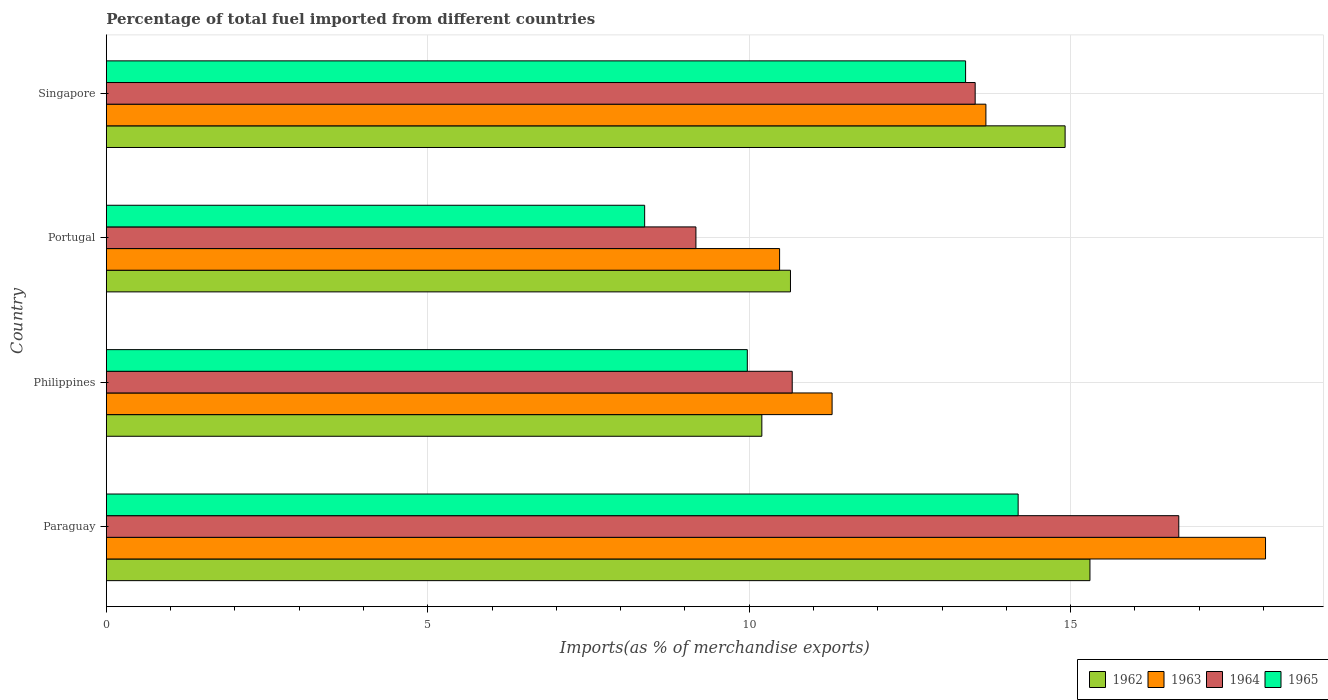Are the number of bars on each tick of the Y-axis equal?
Your answer should be very brief. Yes. How many bars are there on the 3rd tick from the top?
Ensure brevity in your answer.  4. What is the label of the 1st group of bars from the top?
Provide a succinct answer. Singapore. In how many cases, is the number of bars for a given country not equal to the number of legend labels?
Offer a very short reply. 0. What is the percentage of imports to different countries in 1964 in Portugal?
Your response must be concise. 9.17. Across all countries, what is the maximum percentage of imports to different countries in 1962?
Give a very brief answer. 15.3. Across all countries, what is the minimum percentage of imports to different countries in 1964?
Ensure brevity in your answer.  9.17. In which country was the percentage of imports to different countries in 1963 maximum?
Your answer should be compact. Paraguay. What is the total percentage of imports to different countries in 1964 in the graph?
Offer a terse response. 50.03. What is the difference between the percentage of imports to different countries in 1965 in Portugal and that in Singapore?
Your answer should be very brief. -4.99. What is the difference between the percentage of imports to different countries in 1965 in Paraguay and the percentage of imports to different countries in 1964 in Singapore?
Provide a short and direct response. 0.67. What is the average percentage of imports to different countries in 1962 per country?
Give a very brief answer. 12.76. What is the difference between the percentage of imports to different countries in 1962 and percentage of imports to different countries in 1963 in Paraguay?
Give a very brief answer. -2.73. In how many countries, is the percentage of imports to different countries in 1964 greater than 5 %?
Ensure brevity in your answer.  4. What is the ratio of the percentage of imports to different countries in 1962 in Philippines to that in Singapore?
Your answer should be very brief. 0.68. Is the percentage of imports to different countries in 1963 in Philippines less than that in Portugal?
Make the answer very short. No. What is the difference between the highest and the second highest percentage of imports to different countries in 1964?
Your answer should be compact. 3.17. What is the difference between the highest and the lowest percentage of imports to different countries in 1963?
Provide a short and direct response. 7.56. Is the sum of the percentage of imports to different countries in 1965 in Philippines and Portugal greater than the maximum percentage of imports to different countries in 1962 across all countries?
Give a very brief answer. Yes. Is it the case that in every country, the sum of the percentage of imports to different countries in 1963 and percentage of imports to different countries in 1964 is greater than the sum of percentage of imports to different countries in 1962 and percentage of imports to different countries in 1965?
Make the answer very short. No. What does the 4th bar from the top in Singapore represents?
Your answer should be very brief. 1962. What does the 4th bar from the bottom in Portugal represents?
Your answer should be very brief. 1965. Is it the case that in every country, the sum of the percentage of imports to different countries in 1964 and percentage of imports to different countries in 1965 is greater than the percentage of imports to different countries in 1962?
Provide a short and direct response. Yes. Are all the bars in the graph horizontal?
Provide a short and direct response. Yes. How many countries are there in the graph?
Provide a short and direct response. 4. What is the difference between two consecutive major ticks on the X-axis?
Offer a very short reply. 5. Are the values on the major ticks of X-axis written in scientific E-notation?
Provide a succinct answer. No. How are the legend labels stacked?
Provide a short and direct response. Horizontal. What is the title of the graph?
Your answer should be compact. Percentage of total fuel imported from different countries. Does "1964" appear as one of the legend labels in the graph?
Your answer should be very brief. Yes. What is the label or title of the X-axis?
Offer a very short reply. Imports(as % of merchandise exports). What is the Imports(as % of merchandise exports) of 1962 in Paraguay?
Offer a terse response. 15.3. What is the Imports(as % of merchandise exports) in 1963 in Paraguay?
Give a very brief answer. 18.03. What is the Imports(as % of merchandise exports) of 1964 in Paraguay?
Give a very brief answer. 16.68. What is the Imports(as % of merchandise exports) in 1965 in Paraguay?
Your response must be concise. 14.18. What is the Imports(as % of merchandise exports) of 1962 in Philippines?
Make the answer very short. 10.2. What is the Imports(as % of merchandise exports) of 1963 in Philippines?
Offer a very short reply. 11.29. What is the Imports(as % of merchandise exports) of 1964 in Philippines?
Keep it short and to the point. 10.67. What is the Imports(as % of merchandise exports) in 1965 in Philippines?
Offer a very short reply. 9.97. What is the Imports(as % of merchandise exports) of 1962 in Portugal?
Your response must be concise. 10.64. What is the Imports(as % of merchandise exports) in 1963 in Portugal?
Offer a very short reply. 10.47. What is the Imports(as % of merchandise exports) in 1964 in Portugal?
Offer a very short reply. 9.17. What is the Imports(as % of merchandise exports) of 1965 in Portugal?
Give a very brief answer. 8.37. What is the Imports(as % of merchandise exports) in 1962 in Singapore?
Offer a terse response. 14.91. What is the Imports(as % of merchandise exports) in 1963 in Singapore?
Your response must be concise. 13.68. What is the Imports(as % of merchandise exports) in 1964 in Singapore?
Your answer should be very brief. 13.51. What is the Imports(as % of merchandise exports) of 1965 in Singapore?
Offer a very short reply. 13.37. Across all countries, what is the maximum Imports(as % of merchandise exports) of 1962?
Your answer should be very brief. 15.3. Across all countries, what is the maximum Imports(as % of merchandise exports) of 1963?
Provide a succinct answer. 18.03. Across all countries, what is the maximum Imports(as % of merchandise exports) of 1964?
Your response must be concise. 16.68. Across all countries, what is the maximum Imports(as % of merchandise exports) in 1965?
Provide a succinct answer. 14.18. Across all countries, what is the minimum Imports(as % of merchandise exports) of 1962?
Offer a terse response. 10.2. Across all countries, what is the minimum Imports(as % of merchandise exports) of 1963?
Make the answer very short. 10.47. Across all countries, what is the minimum Imports(as % of merchandise exports) in 1964?
Offer a very short reply. 9.17. Across all countries, what is the minimum Imports(as % of merchandise exports) in 1965?
Your answer should be compact. 8.37. What is the total Imports(as % of merchandise exports) of 1962 in the graph?
Provide a short and direct response. 51.05. What is the total Imports(as % of merchandise exports) in 1963 in the graph?
Offer a very short reply. 53.47. What is the total Imports(as % of merchandise exports) of 1964 in the graph?
Offer a very short reply. 50.03. What is the total Imports(as % of merchandise exports) of 1965 in the graph?
Your response must be concise. 45.89. What is the difference between the Imports(as % of merchandise exports) in 1962 in Paraguay and that in Philippines?
Your answer should be very brief. 5.1. What is the difference between the Imports(as % of merchandise exports) of 1963 in Paraguay and that in Philippines?
Ensure brevity in your answer.  6.74. What is the difference between the Imports(as % of merchandise exports) of 1964 in Paraguay and that in Philippines?
Offer a very short reply. 6.01. What is the difference between the Imports(as % of merchandise exports) in 1965 in Paraguay and that in Philippines?
Give a very brief answer. 4.21. What is the difference between the Imports(as % of merchandise exports) of 1962 in Paraguay and that in Portugal?
Offer a very short reply. 4.66. What is the difference between the Imports(as % of merchandise exports) in 1963 in Paraguay and that in Portugal?
Your answer should be very brief. 7.56. What is the difference between the Imports(as % of merchandise exports) of 1964 in Paraguay and that in Portugal?
Offer a very short reply. 7.51. What is the difference between the Imports(as % of merchandise exports) in 1965 in Paraguay and that in Portugal?
Make the answer very short. 5.81. What is the difference between the Imports(as % of merchandise exports) of 1962 in Paraguay and that in Singapore?
Ensure brevity in your answer.  0.39. What is the difference between the Imports(as % of merchandise exports) in 1963 in Paraguay and that in Singapore?
Your response must be concise. 4.35. What is the difference between the Imports(as % of merchandise exports) of 1964 in Paraguay and that in Singapore?
Provide a short and direct response. 3.17. What is the difference between the Imports(as % of merchandise exports) in 1965 in Paraguay and that in Singapore?
Your answer should be compact. 0.82. What is the difference between the Imports(as % of merchandise exports) in 1962 in Philippines and that in Portugal?
Offer a terse response. -0.45. What is the difference between the Imports(as % of merchandise exports) of 1963 in Philippines and that in Portugal?
Offer a very short reply. 0.82. What is the difference between the Imports(as % of merchandise exports) of 1964 in Philippines and that in Portugal?
Offer a terse response. 1.5. What is the difference between the Imports(as % of merchandise exports) in 1965 in Philippines and that in Portugal?
Offer a very short reply. 1.6. What is the difference between the Imports(as % of merchandise exports) in 1962 in Philippines and that in Singapore?
Make the answer very short. -4.72. What is the difference between the Imports(as % of merchandise exports) in 1963 in Philippines and that in Singapore?
Make the answer very short. -2.39. What is the difference between the Imports(as % of merchandise exports) in 1964 in Philippines and that in Singapore?
Make the answer very short. -2.85. What is the difference between the Imports(as % of merchandise exports) in 1965 in Philippines and that in Singapore?
Provide a short and direct response. -3.4. What is the difference between the Imports(as % of merchandise exports) of 1962 in Portugal and that in Singapore?
Ensure brevity in your answer.  -4.27. What is the difference between the Imports(as % of merchandise exports) of 1963 in Portugal and that in Singapore?
Make the answer very short. -3.21. What is the difference between the Imports(as % of merchandise exports) of 1964 in Portugal and that in Singapore?
Make the answer very short. -4.34. What is the difference between the Imports(as % of merchandise exports) in 1965 in Portugal and that in Singapore?
Your response must be concise. -4.99. What is the difference between the Imports(as % of merchandise exports) of 1962 in Paraguay and the Imports(as % of merchandise exports) of 1963 in Philippines?
Keep it short and to the point. 4.01. What is the difference between the Imports(as % of merchandise exports) of 1962 in Paraguay and the Imports(as % of merchandise exports) of 1964 in Philippines?
Ensure brevity in your answer.  4.63. What is the difference between the Imports(as % of merchandise exports) of 1962 in Paraguay and the Imports(as % of merchandise exports) of 1965 in Philippines?
Your answer should be very brief. 5.33. What is the difference between the Imports(as % of merchandise exports) in 1963 in Paraguay and the Imports(as % of merchandise exports) in 1964 in Philippines?
Your response must be concise. 7.36. What is the difference between the Imports(as % of merchandise exports) of 1963 in Paraguay and the Imports(as % of merchandise exports) of 1965 in Philippines?
Your answer should be compact. 8.06. What is the difference between the Imports(as % of merchandise exports) in 1964 in Paraguay and the Imports(as % of merchandise exports) in 1965 in Philippines?
Provide a succinct answer. 6.71. What is the difference between the Imports(as % of merchandise exports) in 1962 in Paraguay and the Imports(as % of merchandise exports) in 1963 in Portugal?
Your response must be concise. 4.83. What is the difference between the Imports(as % of merchandise exports) in 1962 in Paraguay and the Imports(as % of merchandise exports) in 1964 in Portugal?
Ensure brevity in your answer.  6.13. What is the difference between the Imports(as % of merchandise exports) of 1962 in Paraguay and the Imports(as % of merchandise exports) of 1965 in Portugal?
Provide a succinct answer. 6.93. What is the difference between the Imports(as % of merchandise exports) of 1963 in Paraguay and the Imports(as % of merchandise exports) of 1964 in Portugal?
Offer a terse response. 8.86. What is the difference between the Imports(as % of merchandise exports) of 1963 in Paraguay and the Imports(as % of merchandise exports) of 1965 in Portugal?
Your response must be concise. 9.66. What is the difference between the Imports(as % of merchandise exports) of 1964 in Paraguay and the Imports(as % of merchandise exports) of 1965 in Portugal?
Your response must be concise. 8.31. What is the difference between the Imports(as % of merchandise exports) in 1962 in Paraguay and the Imports(as % of merchandise exports) in 1963 in Singapore?
Give a very brief answer. 1.62. What is the difference between the Imports(as % of merchandise exports) of 1962 in Paraguay and the Imports(as % of merchandise exports) of 1964 in Singapore?
Make the answer very short. 1.79. What is the difference between the Imports(as % of merchandise exports) of 1962 in Paraguay and the Imports(as % of merchandise exports) of 1965 in Singapore?
Your answer should be very brief. 1.93. What is the difference between the Imports(as % of merchandise exports) of 1963 in Paraguay and the Imports(as % of merchandise exports) of 1964 in Singapore?
Your response must be concise. 4.52. What is the difference between the Imports(as % of merchandise exports) in 1963 in Paraguay and the Imports(as % of merchandise exports) in 1965 in Singapore?
Offer a terse response. 4.67. What is the difference between the Imports(as % of merchandise exports) of 1964 in Paraguay and the Imports(as % of merchandise exports) of 1965 in Singapore?
Offer a very short reply. 3.32. What is the difference between the Imports(as % of merchandise exports) of 1962 in Philippines and the Imports(as % of merchandise exports) of 1963 in Portugal?
Provide a succinct answer. -0.28. What is the difference between the Imports(as % of merchandise exports) of 1962 in Philippines and the Imports(as % of merchandise exports) of 1964 in Portugal?
Offer a terse response. 1.03. What is the difference between the Imports(as % of merchandise exports) in 1962 in Philippines and the Imports(as % of merchandise exports) in 1965 in Portugal?
Provide a succinct answer. 1.82. What is the difference between the Imports(as % of merchandise exports) in 1963 in Philippines and the Imports(as % of merchandise exports) in 1964 in Portugal?
Make the answer very short. 2.12. What is the difference between the Imports(as % of merchandise exports) in 1963 in Philippines and the Imports(as % of merchandise exports) in 1965 in Portugal?
Your response must be concise. 2.92. What is the difference between the Imports(as % of merchandise exports) in 1964 in Philippines and the Imports(as % of merchandise exports) in 1965 in Portugal?
Offer a very short reply. 2.3. What is the difference between the Imports(as % of merchandise exports) in 1962 in Philippines and the Imports(as % of merchandise exports) in 1963 in Singapore?
Your answer should be compact. -3.49. What is the difference between the Imports(as % of merchandise exports) in 1962 in Philippines and the Imports(as % of merchandise exports) in 1964 in Singapore?
Offer a terse response. -3.32. What is the difference between the Imports(as % of merchandise exports) in 1962 in Philippines and the Imports(as % of merchandise exports) in 1965 in Singapore?
Provide a short and direct response. -3.17. What is the difference between the Imports(as % of merchandise exports) in 1963 in Philippines and the Imports(as % of merchandise exports) in 1964 in Singapore?
Make the answer very short. -2.23. What is the difference between the Imports(as % of merchandise exports) of 1963 in Philippines and the Imports(as % of merchandise exports) of 1965 in Singapore?
Your answer should be very brief. -2.08. What is the difference between the Imports(as % of merchandise exports) of 1964 in Philippines and the Imports(as % of merchandise exports) of 1965 in Singapore?
Offer a terse response. -2.7. What is the difference between the Imports(as % of merchandise exports) in 1962 in Portugal and the Imports(as % of merchandise exports) in 1963 in Singapore?
Your answer should be compact. -3.04. What is the difference between the Imports(as % of merchandise exports) in 1962 in Portugal and the Imports(as % of merchandise exports) in 1964 in Singapore?
Ensure brevity in your answer.  -2.87. What is the difference between the Imports(as % of merchandise exports) in 1962 in Portugal and the Imports(as % of merchandise exports) in 1965 in Singapore?
Offer a terse response. -2.72. What is the difference between the Imports(as % of merchandise exports) of 1963 in Portugal and the Imports(as % of merchandise exports) of 1964 in Singapore?
Your answer should be compact. -3.04. What is the difference between the Imports(as % of merchandise exports) of 1963 in Portugal and the Imports(as % of merchandise exports) of 1965 in Singapore?
Your answer should be compact. -2.89. What is the difference between the Imports(as % of merchandise exports) in 1964 in Portugal and the Imports(as % of merchandise exports) in 1965 in Singapore?
Keep it short and to the point. -4.19. What is the average Imports(as % of merchandise exports) in 1962 per country?
Give a very brief answer. 12.76. What is the average Imports(as % of merchandise exports) of 1963 per country?
Give a very brief answer. 13.37. What is the average Imports(as % of merchandise exports) in 1964 per country?
Offer a very short reply. 12.51. What is the average Imports(as % of merchandise exports) in 1965 per country?
Your response must be concise. 11.47. What is the difference between the Imports(as % of merchandise exports) in 1962 and Imports(as % of merchandise exports) in 1963 in Paraguay?
Your answer should be compact. -2.73. What is the difference between the Imports(as % of merchandise exports) in 1962 and Imports(as % of merchandise exports) in 1964 in Paraguay?
Offer a terse response. -1.38. What is the difference between the Imports(as % of merchandise exports) in 1962 and Imports(as % of merchandise exports) in 1965 in Paraguay?
Provide a succinct answer. 1.12. What is the difference between the Imports(as % of merchandise exports) in 1963 and Imports(as % of merchandise exports) in 1964 in Paraguay?
Your answer should be compact. 1.35. What is the difference between the Imports(as % of merchandise exports) in 1963 and Imports(as % of merchandise exports) in 1965 in Paraguay?
Ensure brevity in your answer.  3.85. What is the difference between the Imports(as % of merchandise exports) of 1964 and Imports(as % of merchandise exports) of 1965 in Paraguay?
Give a very brief answer. 2.5. What is the difference between the Imports(as % of merchandise exports) in 1962 and Imports(as % of merchandise exports) in 1963 in Philippines?
Give a very brief answer. -1.09. What is the difference between the Imports(as % of merchandise exports) of 1962 and Imports(as % of merchandise exports) of 1964 in Philippines?
Your answer should be compact. -0.47. What is the difference between the Imports(as % of merchandise exports) in 1962 and Imports(as % of merchandise exports) in 1965 in Philippines?
Ensure brevity in your answer.  0.23. What is the difference between the Imports(as % of merchandise exports) in 1963 and Imports(as % of merchandise exports) in 1964 in Philippines?
Your answer should be very brief. 0.62. What is the difference between the Imports(as % of merchandise exports) of 1963 and Imports(as % of merchandise exports) of 1965 in Philippines?
Offer a very short reply. 1.32. What is the difference between the Imports(as % of merchandise exports) of 1964 and Imports(as % of merchandise exports) of 1965 in Philippines?
Keep it short and to the point. 0.7. What is the difference between the Imports(as % of merchandise exports) in 1962 and Imports(as % of merchandise exports) in 1963 in Portugal?
Your answer should be compact. 0.17. What is the difference between the Imports(as % of merchandise exports) of 1962 and Imports(as % of merchandise exports) of 1964 in Portugal?
Your response must be concise. 1.47. What is the difference between the Imports(as % of merchandise exports) of 1962 and Imports(as % of merchandise exports) of 1965 in Portugal?
Give a very brief answer. 2.27. What is the difference between the Imports(as % of merchandise exports) in 1963 and Imports(as % of merchandise exports) in 1964 in Portugal?
Your response must be concise. 1.3. What is the difference between the Imports(as % of merchandise exports) in 1963 and Imports(as % of merchandise exports) in 1965 in Portugal?
Your answer should be very brief. 2.1. What is the difference between the Imports(as % of merchandise exports) in 1964 and Imports(as % of merchandise exports) in 1965 in Portugal?
Make the answer very short. 0.8. What is the difference between the Imports(as % of merchandise exports) of 1962 and Imports(as % of merchandise exports) of 1963 in Singapore?
Provide a short and direct response. 1.23. What is the difference between the Imports(as % of merchandise exports) of 1962 and Imports(as % of merchandise exports) of 1964 in Singapore?
Provide a short and direct response. 1.4. What is the difference between the Imports(as % of merchandise exports) of 1962 and Imports(as % of merchandise exports) of 1965 in Singapore?
Provide a succinct answer. 1.55. What is the difference between the Imports(as % of merchandise exports) in 1963 and Imports(as % of merchandise exports) in 1964 in Singapore?
Offer a terse response. 0.17. What is the difference between the Imports(as % of merchandise exports) of 1963 and Imports(as % of merchandise exports) of 1965 in Singapore?
Give a very brief answer. 0.32. What is the difference between the Imports(as % of merchandise exports) in 1964 and Imports(as % of merchandise exports) in 1965 in Singapore?
Provide a succinct answer. 0.15. What is the ratio of the Imports(as % of merchandise exports) of 1962 in Paraguay to that in Philippines?
Keep it short and to the point. 1.5. What is the ratio of the Imports(as % of merchandise exports) in 1963 in Paraguay to that in Philippines?
Your answer should be very brief. 1.6. What is the ratio of the Imports(as % of merchandise exports) of 1964 in Paraguay to that in Philippines?
Ensure brevity in your answer.  1.56. What is the ratio of the Imports(as % of merchandise exports) of 1965 in Paraguay to that in Philippines?
Make the answer very short. 1.42. What is the ratio of the Imports(as % of merchandise exports) of 1962 in Paraguay to that in Portugal?
Provide a succinct answer. 1.44. What is the ratio of the Imports(as % of merchandise exports) in 1963 in Paraguay to that in Portugal?
Provide a short and direct response. 1.72. What is the ratio of the Imports(as % of merchandise exports) in 1964 in Paraguay to that in Portugal?
Give a very brief answer. 1.82. What is the ratio of the Imports(as % of merchandise exports) in 1965 in Paraguay to that in Portugal?
Provide a succinct answer. 1.69. What is the ratio of the Imports(as % of merchandise exports) of 1962 in Paraguay to that in Singapore?
Make the answer very short. 1.03. What is the ratio of the Imports(as % of merchandise exports) in 1963 in Paraguay to that in Singapore?
Keep it short and to the point. 1.32. What is the ratio of the Imports(as % of merchandise exports) in 1964 in Paraguay to that in Singapore?
Your answer should be compact. 1.23. What is the ratio of the Imports(as % of merchandise exports) in 1965 in Paraguay to that in Singapore?
Your answer should be very brief. 1.06. What is the ratio of the Imports(as % of merchandise exports) of 1962 in Philippines to that in Portugal?
Offer a very short reply. 0.96. What is the ratio of the Imports(as % of merchandise exports) of 1963 in Philippines to that in Portugal?
Provide a short and direct response. 1.08. What is the ratio of the Imports(as % of merchandise exports) of 1964 in Philippines to that in Portugal?
Your answer should be very brief. 1.16. What is the ratio of the Imports(as % of merchandise exports) in 1965 in Philippines to that in Portugal?
Provide a succinct answer. 1.19. What is the ratio of the Imports(as % of merchandise exports) of 1962 in Philippines to that in Singapore?
Offer a terse response. 0.68. What is the ratio of the Imports(as % of merchandise exports) in 1963 in Philippines to that in Singapore?
Your answer should be very brief. 0.83. What is the ratio of the Imports(as % of merchandise exports) in 1964 in Philippines to that in Singapore?
Give a very brief answer. 0.79. What is the ratio of the Imports(as % of merchandise exports) in 1965 in Philippines to that in Singapore?
Keep it short and to the point. 0.75. What is the ratio of the Imports(as % of merchandise exports) in 1962 in Portugal to that in Singapore?
Keep it short and to the point. 0.71. What is the ratio of the Imports(as % of merchandise exports) of 1963 in Portugal to that in Singapore?
Give a very brief answer. 0.77. What is the ratio of the Imports(as % of merchandise exports) in 1964 in Portugal to that in Singapore?
Provide a short and direct response. 0.68. What is the ratio of the Imports(as % of merchandise exports) in 1965 in Portugal to that in Singapore?
Your response must be concise. 0.63. What is the difference between the highest and the second highest Imports(as % of merchandise exports) in 1962?
Give a very brief answer. 0.39. What is the difference between the highest and the second highest Imports(as % of merchandise exports) in 1963?
Provide a succinct answer. 4.35. What is the difference between the highest and the second highest Imports(as % of merchandise exports) of 1964?
Keep it short and to the point. 3.17. What is the difference between the highest and the second highest Imports(as % of merchandise exports) in 1965?
Offer a very short reply. 0.82. What is the difference between the highest and the lowest Imports(as % of merchandise exports) of 1962?
Your answer should be very brief. 5.1. What is the difference between the highest and the lowest Imports(as % of merchandise exports) of 1963?
Provide a short and direct response. 7.56. What is the difference between the highest and the lowest Imports(as % of merchandise exports) of 1964?
Your answer should be compact. 7.51. What is the difference between the highest and the lowest Imports(as % of merchandise exports) in 1965?
Your answer should be very brief. 5.81. 